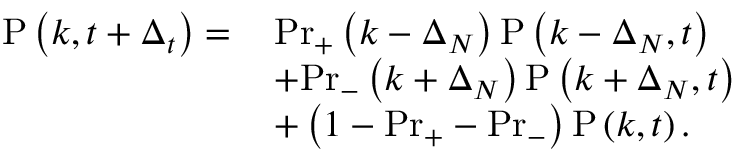<formula> <loc_0><loc_0><loc_500><loc_500>\begin{array} { r l } { P \left ( k , t + \Delta _ { t } \right ) = \, } & { P r _ { + } \left ( k - \Delta _ { N } \right ) P \left ( k - \Delta _ { N } , t \right ) } \\ & { + P r _ { - } \left ( k + \Delta _ { N } \right ) P \left ( k + \Delta _ { N } , t \right ) } \\ & { + \left ( 1 - P r _ { + } - P r _ { - } \right ) P \left ( k , t \right ) . } \end{array}</formula> 